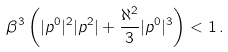<formula> <loc_0><loc_0><loc_500><loc_500>\beta ^ { 3 } \left ( | p ^ { 0 } | ^ { 2 } | p ^ { 2 } | + \frac { \aleph ^ { 2 } } { 3 } | p ^ { 0 } | ^ { 3 } \right ) < 1 \, .</formula> 